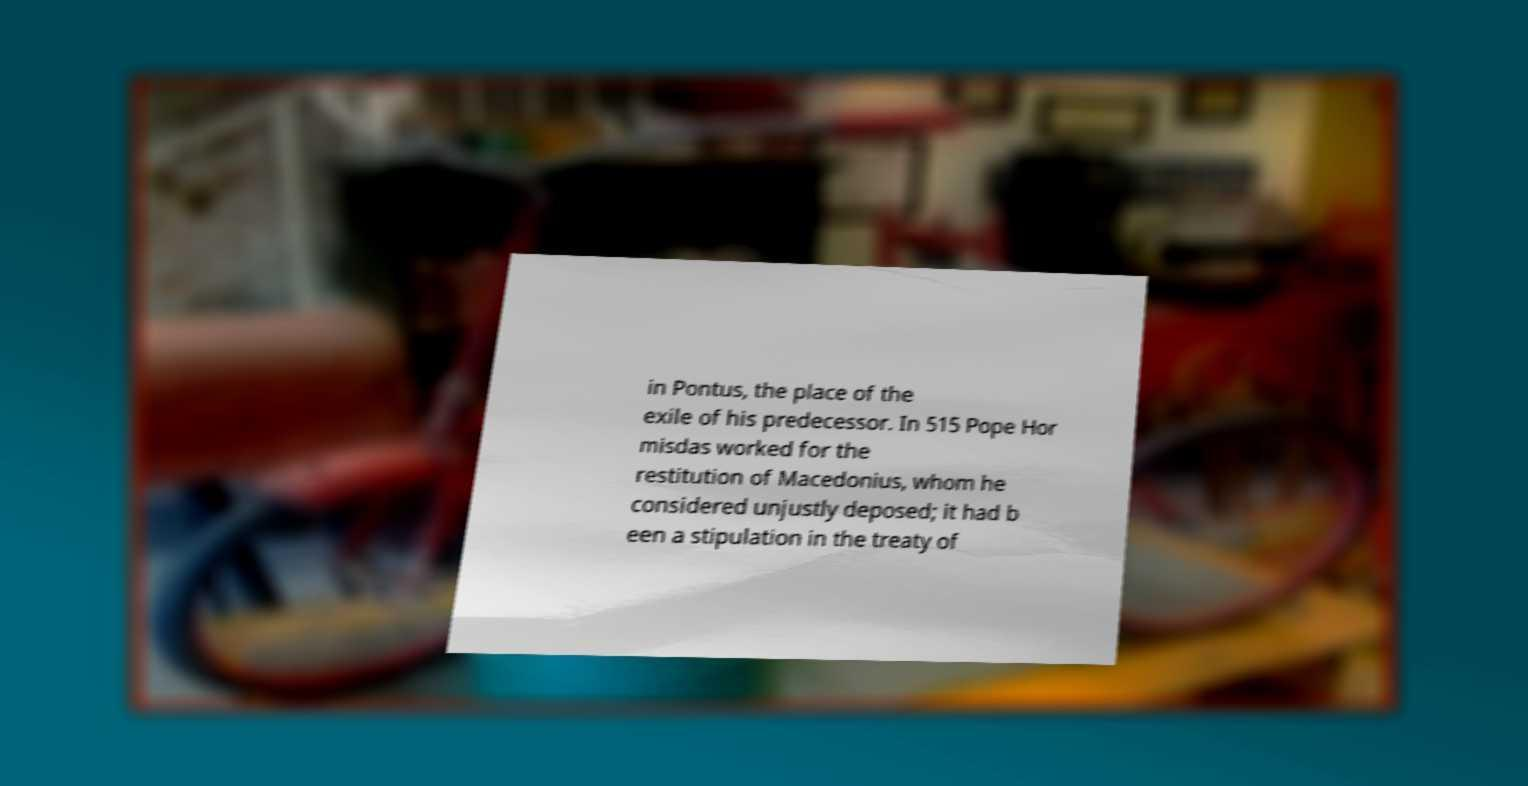Can you accurately transcribe the text from the provided image for me? in Pontus, the place of the exile of his predecessor. In 515 Pope Hor misdas worked for the restitution of Macedonius, whom he considered unjustly deposed; it had b een a stipulation in the treaty of 